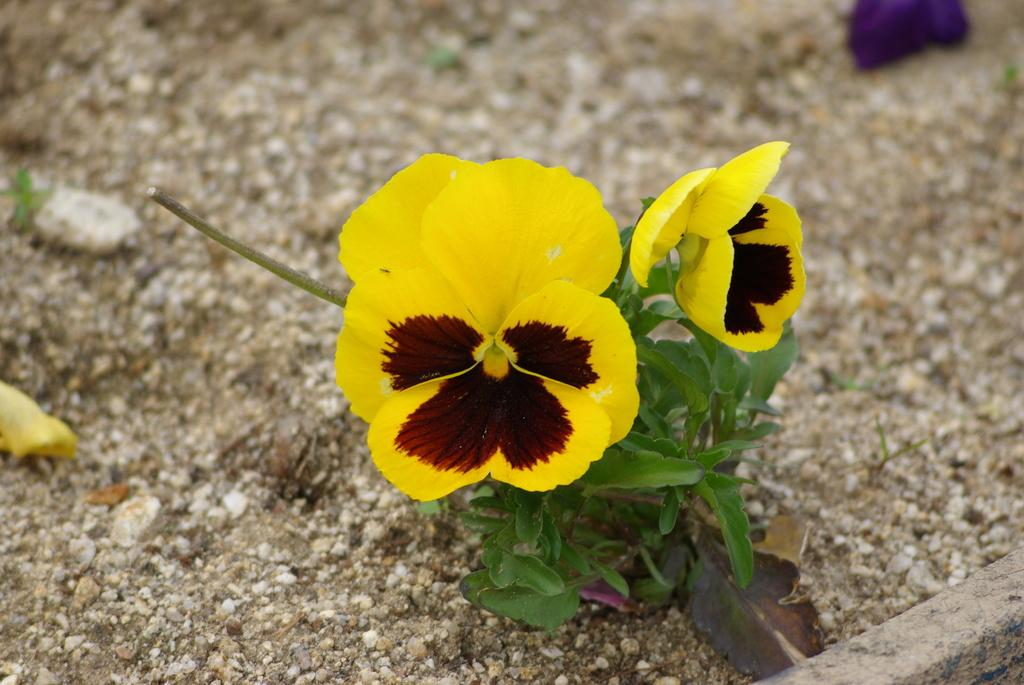What type of flowers can be seen in the image? There are yellow flowers in the image. What is the plant associated with the flowers? There is a plant associated with the flowers in the image. What can be seen below the flowers and plant? The ground is visible in the image. What is the condition of the top part of the image? The top of the image has a blurred view. What else is present in the image besides the flowers and plant? There are objects present in the image. Can you hear the duck playing the guitar in the image? There is no duck or guitar present in the image, so it is not possible to hear any music being played. 